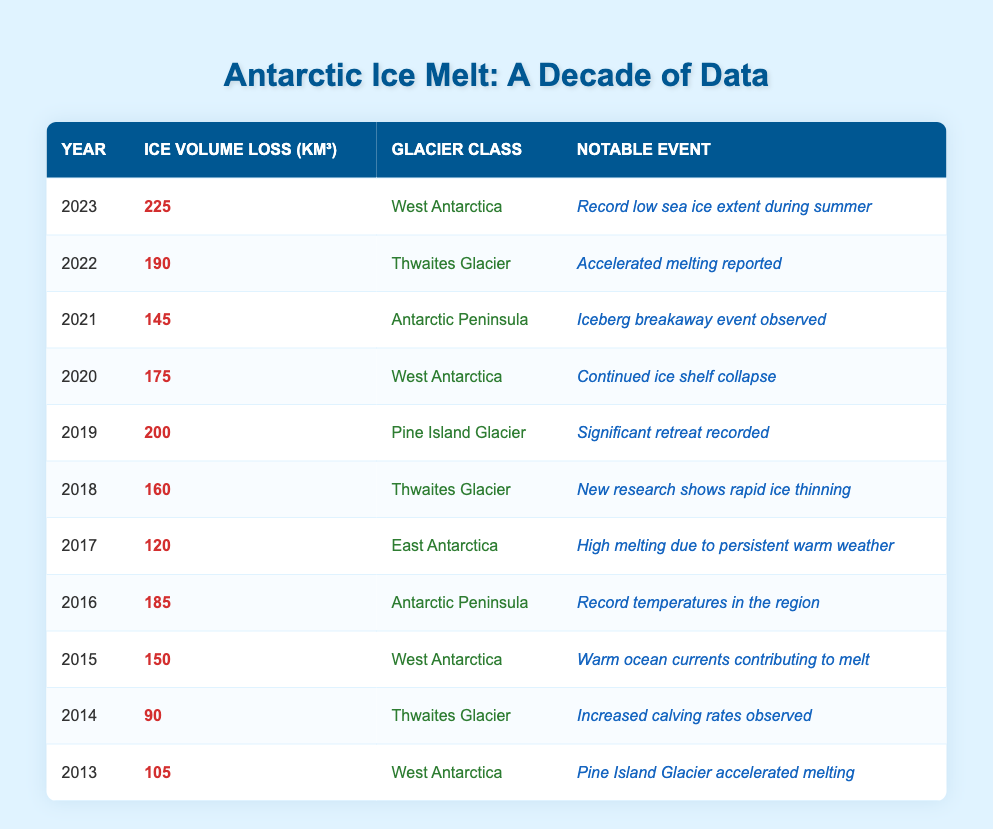What was the ice volume loss in Antarctica in 2023? In the table, the entry for the year 2023 shows that the ice volume loss was recorded as 225 cubic kilometers.
Answer: 225 Which glacier class experienced the highest ice volume loss in the past decade? By reviewing the volume losses over the years, West Antarctica has the highest singular loss at 225 cubic kilometers in 2023.
Answer: West Antarctica How much ice volume was lost in total from 2013 to 2023? Adding the ice volume losses for each year together gives: (105 + 90 + 150 + 185 + 120 + 160 + 200 + 175 + 145 + 190 + 225) = 1,705 cubic kilometers.
Answer: 1,705 Was there a noticeable increase in ice volume loss from 2018 to 2019? In 2018, the ice volume loss was 160 cubic kilometers, and it rose to 200 cubic kilometers in 2019. This indicates an increase.
Answer: Yes What year had the lowest ice volume loss and what was the amount? The year with the lowest ice volume loss was 2014, which recorded a loss of 90 cubic kilometers.
Answer: 2014, 90 What was the average ice volume loss per year over the last decade? Summing the total loss gives 1,705 cubic kilometers, with 11 years in the dataset, thus the average loss is 1,705/11 = 155.91 cubic kilometers, which rounds to 156 cubic kilometers.
Answer: 156 Did any notable event in 2021 involve a breakaway event related to icebergs? The table indicates that in 2021, there was indeed an "Iceberg breakaway event observed," confirming the occurrence of such an event.
Answer: Yes In which year did the Thwaites Glacier experience the most significant loss? Looking at the table, 2022 was the year Thwaites Glacier recorded a loss of 190 cubic kilometers, the highest for this glacier class.
Answer: 2022 What can be inferred about the trend in ice volume loss from the data provided? The data shows an overall increasing trend in ice volume loss, particularly notable spikes in years like 2022 and 2023.
Answer: Increasing trend 